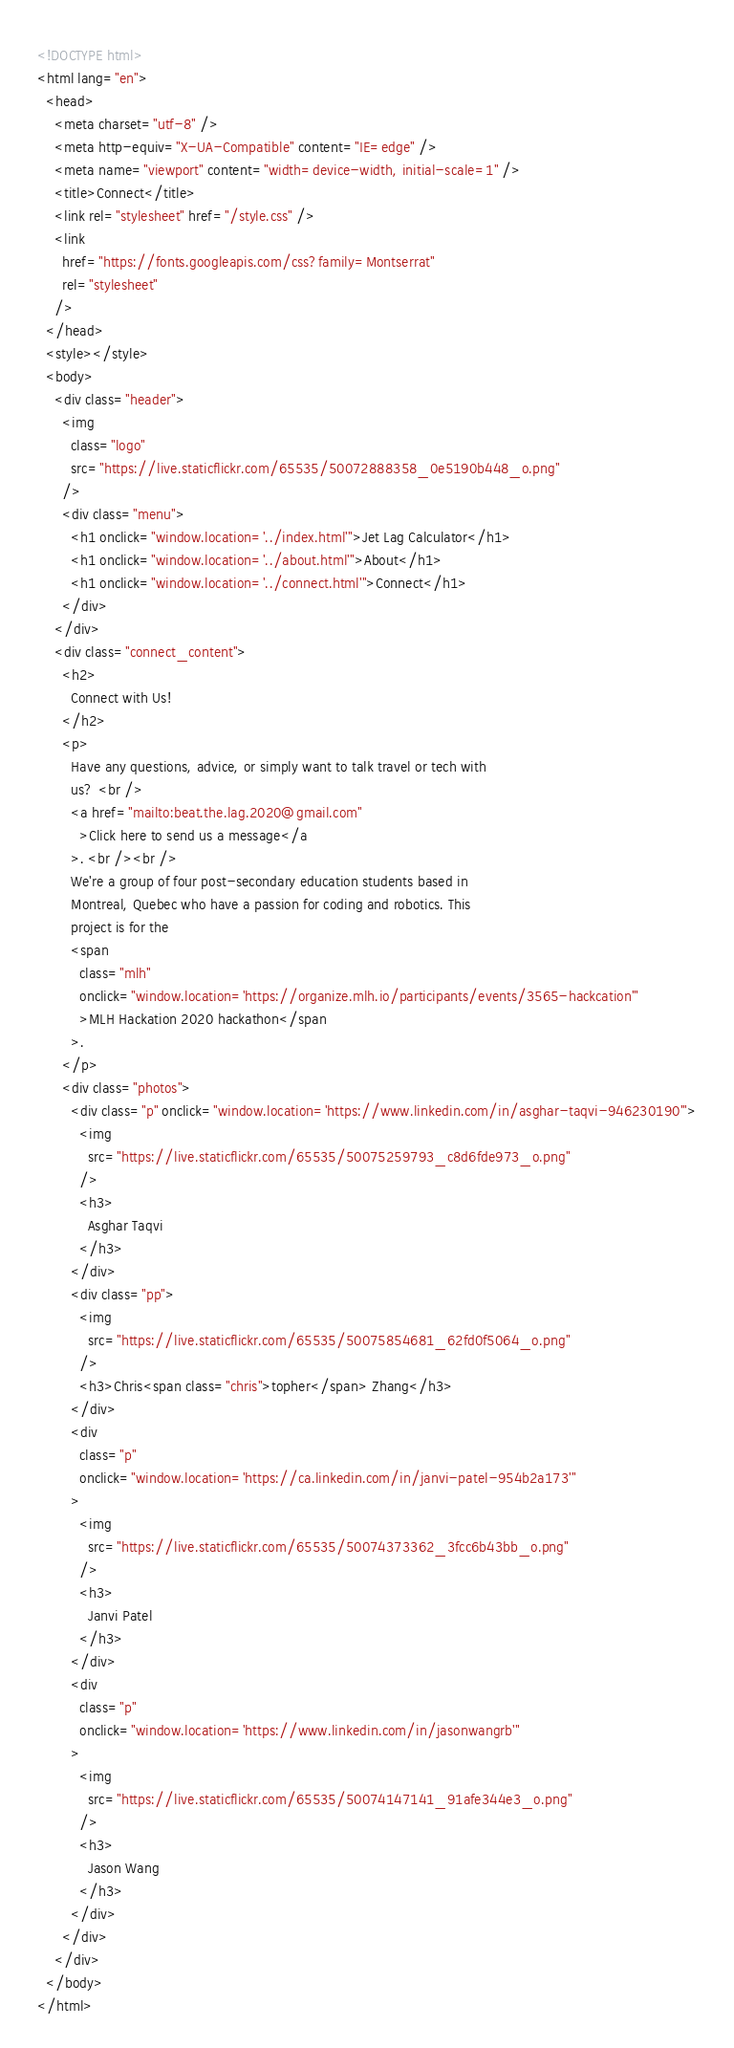<code> <loc_0><loc_0><loc_500><loc_500><_HTML_><!DOCTYPE html>
<html lang="en">
  <head>
    <meta charset="utf-8" />
    <meta http-equiv="X-UA-Compatible" content="IE=edge" />
    <meta name="viewport" content="width=device-width, initial-scale=1" />
    <title>Connect</title>
    <link rel="stylesheet" href="/style.css" />
    <link
      href="https://fonts.googleapis.com/css?family=Montserrat"
      rel="stylesheet"
    />
  </head>
  <style></style>
  <body>
    <div class="header">
      <img
        class="logo"
        src="https://live.staticflickr.com/65535/50072888358_0e5190b448_o.png"
      />
      <div class="menu">
        <h1 onclick="window.location='../index.html'">Jet Lag Calculator</h1>
        <h1 onclick="window.location='../about.html'">About</h1>
        <h1 onclick="window.location='../connect.html'">Connect</h1>
      </div>
    </div>
    <div class="connect_content">
      <h2>
        Connect with Us!
      </h2>
      <p>
        Have any questions, advice, or simply want to talk travel or tech with
        us? <br />
        <a href="mailto:beat.the.lag.2020@gmail.com"
          >Click here to send us a message</a
        >. <br /><br />
        We're a group of four post-secondary education students based in
        Montreal, Quebec who have a passion for coding and robotics. This
        project is for the
        <span
          class="mlh"
          onclick="window.location='https://organize.mlh.io/participants/events/3565-hackcation'"
          >MLH Hackation 2020 hackathon</span
        >.
      </p>
      <div class="photos">
        <div class="p" onclick="window.location='https://www.linkedin.com/in/asghar-taqvi-946230190'">
          <img
            src="https://live.staticflickr.com/65535/50075259793_c8d6fde973_o.png"
          />
          <h3>
            Asghar Taqvi
          </h3>
        </div>
        <div class="pp">
          <img
            src="https://live.staticflickr.com/65535/50075854681_62fd0f5064_o.png"
          />
          <h3>Chris<span class="chris">topher</span> Zhang</h3>
        </div>
        <div
          class="p"
          onclick="window.location='https://ca.linkedin.com/in/janvi-patel-954b2a173'"
        >
          <img
            src="https://live.staticflickr.com/65535/50074373362_3fcc6b43bb_o.png"
          />
          <h3>
            Janvi Patel
          </h3>
        </div>
        <div
          class="p"
          onclick="window.location='https://www.linkedin.com/in/jasonwangrb'"
        >
          <img
            src="https://live.staticflickr.com/65535/50074147141_91afe344e3_o.png"
          />
          <h3>
            Jason Wang
          </h3>
        </div>
      </div>
    </div>
  </body>
</html>
</code> 